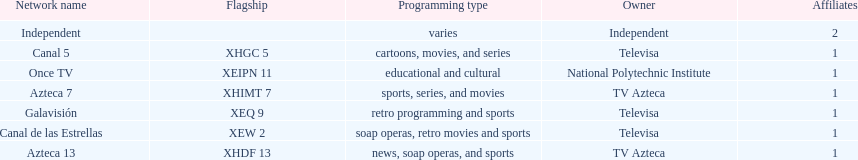Write the full table. {'header': ['Network name', 'Flagship', 'Programming type', 'Owner', 'Affiliates'], 'rows': [['Independent', '', 'varies', 'Independent', '2'], ['Canal 5', 'XHGC 5', 'cartoons, movies, and series', 'Televisa', '1'], ['Once TV', 'XEIPN 11', 'educational and cultural', 'National Polytechnic Institute', '1'], ['Azteca 7', 'XHIMT 7', 'sports, series, and movies', 'TV Azteca', '1'], ['Galavisión', 'XEQ 9', 'retro programming and sports', 'Televisa', '1'], ['Canal de las Estrellas', 'XEW 2', 'soap operas, retro movies and sports', 'Televisa', '1'], ['Azteca 13', 'XHDF 13', 'news, soap operas, and sports', 'TV Azteca', '1']]} What is the number of networks that are owned by televisa? 3. 